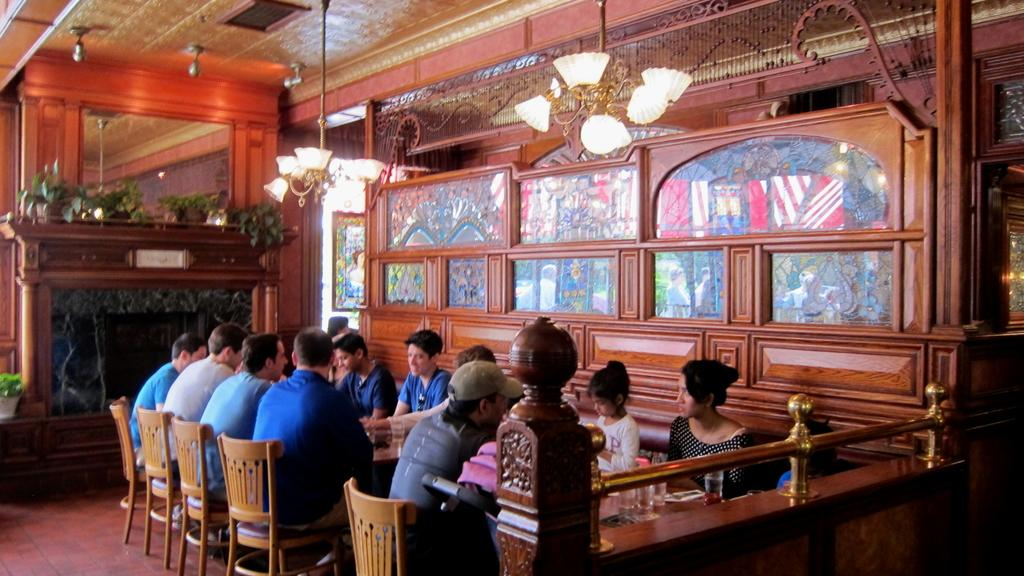What are the people in the image doing? There is a group of people sitting on chairs in the image. What is in front of the chairs? There is a table in front of the chairs. What can be seen on the table? There are glasses and other objects on the table. What can be used to provide illumination in the image? There is a light in the image. What is visible above the people and table? There is a roof visible in the image. What type of metal is used to construct the cars in the image? There are no cars present in the image; it features a group of people sitting on chairs with a table in front of them. 